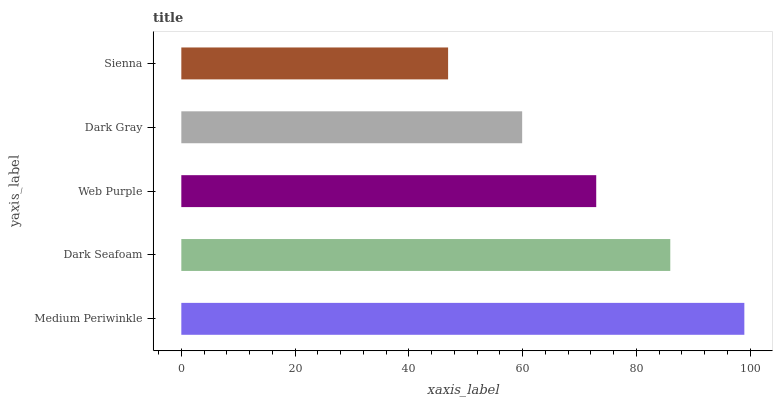Is Sienna the minimum?
Answer yes or no. Yes. Is Medium Periwinkle the maximum?
Answer yes or no. Yes. Is Dark Seafoam the minimum?
Answer yes or no. No. Is Dark Seafoam the maximum?
Answer yes or no. No. Is Medium Periwinkle greater than Dark Seafoam?
Answer yes or no. Yes. Is Dark Seafoam less than Medium Periwinkle?
Answer yes or no. Yes. Is Dark Seafoam greater than Medium Periwinkle?
Answer yes or no. No. Is Medium Periwinkle less than Dark Seafoam?
Answer yes or no. No. Is Web Purple the high median?
Answer yes or no. Yes. Is Web Purple the low median?
Answer yes or no. Yes. Is Dark Seafoam the high median?
Answer yes or no. No. Is Sienna the low median?
Answer yes or no. No. 